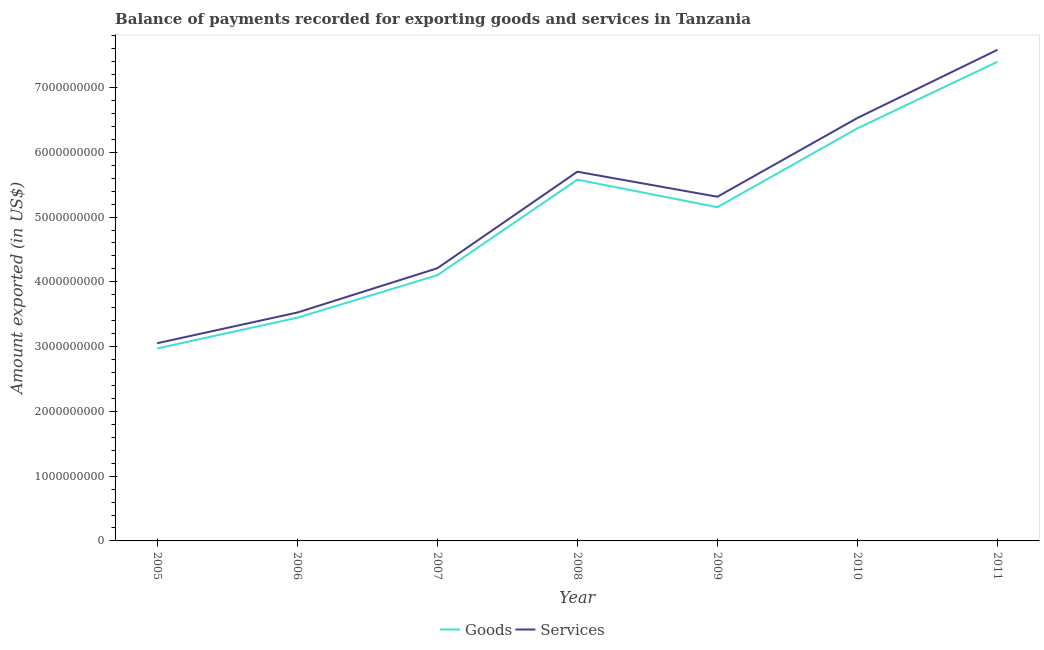How many different coloured lines are there?
Provide a short and direct response. 2. Is the number of lines equal to the number of legend labels?
Your answer should be compact. Yes. What is the amount of goods exported in 2011?
Your answer should be very brief. 7.40e+09. Across all years, what is the maximum amount of services exported?
Provide a succinct answer. 7.58e+09. Across all years, what is the minimum amount of services exported?
Offer a very short reply. 3.05e+09. In which year was the amount of services exported maximum?
Keep it short and to the point. 2011. In which year was the amount of services exported minimum?
Your response must be concise. 2005. What is the total amount of goods exported in the graph?
Your answer should be compact. 3.50e+1. What is the difference between the amount of goods exported in 2005 and that in 2007?
Offer a very short reply. -1.13e+09. What is the difference between the amount of services exported in 2011 and the amount of goods exported in 2005?
Offer a terse response. 4.61e+09. What is the average amount of goods exported per year?
Provide a succinct answer. 5.00e+09. In the year 2005, what is the difference between the amount of goods exported and amount of services exported?
Offer a very short reply. -8.09e+07. What is the ratio of the amount of services exported in 2006 to that in 2011?
Offer a terse response. 0.47. Is the difference between the amount of services exported in 2009 and 2010 greater than the difference between the amount of goods exported in 2009 and 2010?
Your answer should be compact. Yes. What is the difference between the highest and the second highest amount of goods exported?
Provide a succinct answer. 1.03e+09. What is the difference between the highest and the lowest amount of goods exported?
Give a very brief answer. 4.43e+09. In how many years, is the amount of goods exported greater than the average amount of goods exported taken over all years?
Provide a short and direct response. 4. Does the amount of goods exported monotonically increase over the years?
Ensure brevity in your answer.  No. Is the amount of goods exported strictly less than the amount of services exported over the years?
Provide a succinct answer. Yes. How many years are there in the graph?
Ensure brevity in your answer.  7. What is the difference between two consecutive major ticks on the Y-axis?
Your answer should be compact. 1.00e+09. Are the values on the major ticks of Y-axis written in scientific E-notation?
Offer a terse response. No. Does the graph contain any zero values?
Your response must be concise. No. Where does the legend appear in the graph?
Keep it short and to the point. Bottom center. How are the legend labels stacked?
Offer a very short reply. Horizontal. What is the title of the graph?
Make the answer very short. Balance of payments recorded for exporting goods and services in Tanzania. Does "Long-term debt" appear as one of the legend labels in the graph?
Make the answer very short. No. What is the label or title of the Y-axis?
Your response must be concise. Amount exported (in US$). What is the Amount exported (in US$) of Goods in 2005?
Provide a short and direct response. 2.97e+09. What is the Amount exported (in US$) in Services in 2005?
Your answer should be very brief. 3.05e+09. What is the Amount exported (in US$) of Goods in 2006?
Your answer should be compact. 3.45e+09. What is the Amount exported (in US$) of Services in 2006?
Offer a very short reply. 3.53e+09. What is the Amount exported (in US$) of Goods in 2007?
Keep it short and to the point. 4.10e+09. What is the Amount exported (in US$) in Services in 2007?
Give a very brief answer. 4.21e+09. What is the Amount exported (in US$) of Goods in 2008?
Your answer should be very brief. 5.58e+09. What is the Amount exported (in US$) in Services in 2008?
Your answer should be very brief. 5.70e+09. What is the Amount exported (in US$) of Goods in 2009?
Offer a very short reply. 5.15e+09. What is the Amount exported (in US$) of Services in 2009?
Offer a terse response. 5.31e+09. What is the Amount exported (in US$) of Goods in 2010?
Make the answer very short. 6.37e+09. What is the Amount exported (in US$) in Services in 2010?
Ensure brevity in your answer.  6.53e+09. What is the Amount exported (in US$) of Goods in 2011?
Your answer should be compact. 7.40e+09. What is the Amount exported (in US$) in Services in 2011?
Your answer should be very brief. 7.58e+09. Across all years, what is the maximum Amount exported (in US$) in Goods?
Your answer should be very brief. 7.40e+09. Across all years, what is the maximum Amount exported (in US$) of Services?
Your answer should be compact. 7.58e+09. Across all years, what is the minimum Amount exported (in US$) in Goods?
Give a very brief answer. 2.97e+09. Across all years, what is the minimum Amount exported (in US$) in Services?
Provide a succinct answer. 3.05e+09. What is the total Amount exported (in US$) of Goods in the graph?
Give a very brief answer. 3.50e+1. What is the total Amount exported (in US$) of Services in the graph?
Your answer should be compact. 3.59e+1. What is the difference between the Amount exported (in US$) of Goods in 2005 and that in 2006?
Your answer should be compact. -4.74e+08. What is the difference between the Amount exported (in US$) in Services in 2005 and that in 2006?
Offer a terse response. -4.73e+08. What is the difference between the Amount exported (in US$) in Goods in 2005 and that in 2007?
Give a very brief answer. -1.13e+09. What is the difference between the Amount exported (in US$) of Services in 2005 and that in 2007?
Keep it short and to the point. -1.16e+09. What is the difference between the Amount exported (in US$) in Goods in 2005 and that in 2008?
Ensure brevity in your answer.  -2.61e+09. What is the difference between the Amount exported (in US$) of Services in 2005 and that in 2008?
Provide a short and direct response. -2.65e+09. What is the difference between the Amount exported (in US$) in Goods in 2005 and that in 2009?
Your answer should be very brief. -2.18e+09. What is the difference between the Amount exported (in US$) in Services in 2005 and that in 2009?
Your response must be concise. -2.26e+09. What is the difference between the Amount exported (in US$) of Goods in 2005 and that in 2010?
Give a very brief answer. -3.40e+09. What is the difference between the Amount exported (in US$) of Services in 2005 and that in 2010?
Make the answer very short. -3.48e+09. What is the difference between the Amount exported (in US$) of Goods in 2005 and that in 2011?
Your answer should be compact. -4.43e+09. What is the difference between the Amount exported (in US$) in Services in 2005 and that in 2011?
Keep it short and to the point. -4.53e+09. What is the difference between the Amount exported (in US$) of Goods in 2006 and that in 2007?
Provide a succinct answer. -6.57e+08. What is the difference between the Amount exported (in US$) in Services in 2006 and that in 2007?
Provide a short and direct response. -6.84e+08. What is the difference between the Amount exported (in US$) of Goods in 2006 and that in 2008?
Keep it short and to the point. -2.13e+09. What is the difference between the Amount exported (in US$) of Services in 2006 and that in 2008?
Keep it short and to the point. -2.17e+09. What is the difference between the Amount exported (in US$) in Goods in 2006 and that in 2009?
Provide a short and direct response. -1.71e+09. What is the difference between the Amount exported (in US$) of Services in 2006 and that in 2009?
Ensure brevity in your answer.  -1.79e+09. What is the difference between the Amount exported (in US$) in Goods in 2006 and that in 2010?
Your answer should be very brief. -2.92e+09. What is the difference between the Amount exported (in US$) in Services in 2006 and that in 2010?
Offer a very short reply. -3.00e+09. What is the difference between the Amount exported (in US$) in Goods in 2006 and that in 2011?
Your answer should be very brief. -3.95e+09. What is the difference between the Amount exported (in US$) in Services in 2006 and that in 2011?
Offer a terse response. -4.06e+09. What is the difference between the Amount exported (in US$) in Goods in 2007 and that in 2008?
Ensure brevity in your answer.  -1.48e+09. What is the difference between the Amount exported (in US$) in Services in 2007 and that in 2008?
Offer a very short reply. -1.49e+09. What is the difference between the Amount exported (in US$) in Goods in 2007 and that in 2009?
Give a very brief answer. -1.05e+09. What is the difference between the Amount exported (in US$) of Services in 2007 and that in 2009?
Make the answer very short. -1.10e+09. What is the difference between the Amount exported (in US$) of Goods in 2007 and that in 2010?
Offer a terse response. -2.27e+09. What is the difference between the Amount exported (in US$) of Services in 2007 and that in 2010?
Your answer should be very brief. -2.32e+09. What is the difference between the Amount exported (in US$) of Goods in 2007 and that in 2011?
Make the answer very short. -3.30e+09. What is the difference between the Amount exported (in US$) in Services in 2007 and that in 2011?
Keep it short and to the point. -3.37e+09. What is the difference between the Amount exported (in US$) of Goods in 2008 and that in 2009?
Your answer should be very brief. 4.25e+08. What is the difference between the Amount exported (in US$) of Services in 2008 and that in 2009?
Make the answer very short. 3.86e+08. What is the difference between the Amount exported (in US$) of Goods in 2008 and that in 2010?
Provide a short and direct response. -7.92e+08. What is the difference between the Amount exported (in US$) of Services in 2008 and that in 2010?
Offer a terse response. -8.30e+08. What is the difference between the Amount exported (in US$) in Goods in 2008 and that in 2011?
Give a very brief answer. -1.82e+09. What is the difference between the Amount exported (in US$) of Services in 2008 and that in 2011?
Your response must be concise. -1.88e+09. What is the difference between the Amount exported (in US$) of Goods in 2009 and that in 2010?
Your answer should be very brief. -1.22e+09. What is the difference between the Amount exported (in US$) of Services in 2009 and that in 2010?
Offer a terse response. -1.22e+09. What is the difference between the Amount exported (in US$) in Goods in 2009 and that in 2011?
Make the answer very short. -2.25e+09. What is the difference between the Amount exported (in US$) of Services in 2009 and that in 2011?
Offer a very short reply. -2.27e+09. What is the difference between the Amount exported (in US$) of Goods in 2010 and that in 2011?
Your answer should be compact. -1.03e+09. What is the difference between the Amount exported (in US$) in Services in 2010 and that in 2011?
Your answer should be compact. -1.05e+09. What is the difference between the Amount exported (in US$) of Goods in 2005 and the Amount exported (in US$) of Services in 2006?
Provide a short and direct response. -5.54e+08. What is the difference between the Amount exported (in US$) of Goods in 2005 and the Amount exported (in US$) of Services in 2007?
Your answer should be compact. -1.24e+09. What is the difference between the Amount exported (in US$) in Goods in 2005 and the Amount exported (in US$) in Services in 2008?
Give a very brief answer. -2.73e+09. What is the difference between the Amount exported (in US$) of Goods in 2005 and the Amount exported (in US$) of Services in 2009?
Offer a terse response. -2.34e+09. What is the difference between the Amount exported (in US$) of Goods in 2005 and the Amount exported (in US$) of Services in 2010?
Offer a very short reply. -3.56e+09. What is the difference between the Amount exported (in US$) of Goods in 2005 and the Amount exported (in US$) of Services in 2011?
Offer a very short reply. -4.61e+09. What is the difference between the Amount exported (in US$) in Goods in 2006 and the Amount exported (in US$) in Services in 2007?
Ensure brevity in your answer.  -7.64e+08. What is the difference between the Amount exported (in US$) of Goods in 2006 and the Amount exported (in US$) of Services in 2008?
Offer a terse response. -2.25e+09. What is the difference between the Amount exported (in US$) of Goods in 2006 and the Amount exported (in US$) of Services in 2009?
Ensure brevity in your answer.  -1.87e+09. What is the difference between the Amount exported (in US$) of Goods in 2006 and the Amount exported (in US$) of Services in 2010?
Your answer should be compact. -3.08e+09. What is the difference between the Amount exported (in US$) of Goods in 2006 and the Amount exported (in US$) of Services in 2011?
Ensure brevity in your answer.  -4.14e+09. What is the difference between the Amount exported (in US$) in Goods in 2007 and the Amount exported (in US$) in Services in 2008?
Provide a short and direct response. -1.60e+09. What is the difference between the Amount exported (in US$) in Goods in 2007 and the Amount exported (in US$) in Services in 2009?
Offer a terse response. -1.21e+09. What is the difference between the Amount exported (in US$) of Goods in 2007 and the Amount exported (in US$) of Services in 2010?
Ensure brevity in your answer.  -2.43e+09. What is the difference between the Amount exported (in US$) in Goods in 2007 and the Amount exported (in US$) in Services in 2011?
Ensure brevity in your answer.  -3.48e+09. What is the difference between the Amount exported (in US$) of Goods in 2008 and the Amount exported (in US$) of Services in 2009?
Offer a terse response. 2.64e+08. What is the difference between the Amount exported (in US$) of Goods in 2008 and the Amount exported (in US$) of Services in 2010?
Make the answer very short. -9.53e+08. What is the difference between the Amount exported (in US$) in Goods in 2008 and the Amount exported (in US$) in Services in 2011?
Offer a very short reply. -2.00e+09. What is the difference between the Amount exported (in US$) in Goods in 2009 and the Amount exported (in US$) in Services in 2010?
Provide a succinct answer. -1.38e+09. What is the difference between the Amount exported (in US$) of Goods in 2009 and the Amount exported (in US$) of Services in 2011?
Provide a short and direct response. -2.43e+09. What is the difference between the Amount exported (in US$) of Goods in 2010 and the Amount exported (in US$) of Services in 2011?
Give a very brief answer. -1.21e+09. What is the average Amount exported (in US$) of Goods per year?
Provide a succinct answer. 5.00e+09. What is the average Amount exported (in US$) of Services per year?
Give a very brief answer. 5.13e+09. In the year 2005, what is the difference between the Amount exported (in US$) in Goods and Amount exported (in US$) in Services?
Keep it short and to the point. -8.09e+07. In the year 2006, what is the difference between the Amount exported (in US$) of Goods and Amount exported (in US$) of Services?
Your response must be concise. -8.03e+07. In the year 2007, what is the difference between the Amount exported (in US$) in Goods and Amount exported (in US$) in Services?
Offer a terse response. -1.07e+08. In the year 2008, what is the difference between the Amount exported (in US$) in Goods and Amount exported (in US$) in Services?
Ensure brevity in your answer.  -1.23e+08. In the year 2009, what is the difference between the Amount exported (in US$) of Goods and Amount exported (in US$) of Services?
Your answer should be very brief. -1.61e+08. In the year 2010, what is the difference between the Amount exported (in US$) of Goods and Amount exported (in US$) of Services?
Offer a very short reply. -1.60e+08. In the year 2011, what is the difference between the Amount exported (in US$) of Goods and Amount exported (in US$) of Services?
Keep it short and to the point. -1.84e+08. What is the ratio of the Amount exported (in US$) in Goods in 2005 to that in 2006?
Your answer should be very brief. 0.86. What is the ratio of the Amount exported (in US$) of Services in 2005 to that in 2006?
Provide a short and direct response. 0.87. What is the ratio of the Amount exported (in US$) of Goods in 2005 to that in 2007?
Your answer should be very brief. 0.72. What is the ratio of the Amount exported (in US$) in Services in 2005 to that in 2007?
Offer a terse response. 0.73. What is the ratio of the Amount exported (in US$) in Goods in 2005 to that in 2008?
Your answer should be compact. 0.53. What is the ratio of the Amount exported (in US$) of Services in 2005 to that in 2008?
Offer a very short reply. 0.54. What is the ratio of the Amount exported (in US$) of Goods in 2005 to that in 2009?
Provide a short and direct response. 0.58. What is the ratio of the Amount exported (in US$) of Services in 2005 to that in 2009?
Your answer should be compact. 0.57. What is the ratio of the Amount exported (in US$) in Goods in 2005 to that in 2010?
Provide a short and direct response. 0.47. What is the ratio of the Amount exported (in US$) of Services in 2005 to that in 2010?
Provide a succinct answer. 0.47. What is the ratio of the Amount exported (in US$) in Goods in 2005 to that in 2011?
Ensure brevity in your answer.  0.4. What is the ratio of the Amount exported (in US$) in Services in 2005 to that in 2011?
Your answer should be compact. 0.4. What is the ratio of the Amount exported (in US$) in Goods in 2006 to that in 2007?
Your response must be concise. 0.84. What is the ratio of the Amount exported (in US$) in Services in 2006 to that in 2007?
Give a very brief answer. 0.84. What is the ratio of the Amount exported (in US$) of Goods in 2006 to that in 2008?
Keep it short and to the point. 0.62. What is the ratio of the Amount exported (in US$) of Services in 2006 to that in 2008?
Make the answer very short. 0.62. What is the ratio of the Amount exported (in US$) of Goods in 2006 to that in 2009?
Provide a short and direct response. 0.67. What is the ratio of the Amount exported (in US$) of Services in 2006 to that in 2009?
Make the answer very short. 0.66. What is the ratio of the Amount exported (in US$) of Goods in 2006 to that in 2010?
Your answer should be very brief. 0.54. What is the ratio of the Amount exported (in US$) in Services in 2006 to that in 2010?
Your answer should be very brief. 0.54. What is the ratio of the Amount exported (in US$) in Goods in 2006 to that in 2011?
Offer a very short reply. 0.47. What is the ratio of the Amount exported (in US$) of Services in 2006 to that in 2011?
Provide a succinct answer. 0.47. What is the ratio of the Amount exported (in US$) in Goods in 2007 to that in 2008?
Provide a succinct answer. 0.74. What is the ratio of the Amount exported (in US$) of Services in 2007 to that in 2008?
Give a very brief answer. 0.74. What is the ratio of the Amount exported (in US$) in Goods in 2007 to that in 2009?
Your response must be concise. 0.8. What is the ratio of the Amount exported (in US$) of Services in 2007 to that in 2009?
Your answer should be very brief. 0.79. What is the ratio of the Amount exported (in US$) of Goods in 2007 to that in 2010?
Offer a very short reply. 0.64. What is the ratio of the Amount exported (in US$) of Services in 2007 to that in 2010?
Ensure brevity in your answer.  0.64. What is the ratio of the Amount exported (in US$) of Goods in 2007 to that in 2011?
Your answer should be very brief. 0.55. What is the ratio of the Amount exported (in US$) in Services in 2007 to that in 2011?
Provide a short and direct response. 0.56. What is the ratio of the Amount exported (in US$) in Goods in 2008 to that in 2009?
Make the answer very short. 1.08. What is the ratio of the Amount exported (in US$) in Services in 2008 to that in 2009?
Ensure brevity in your answer.  1.07. What is the ratio of the Amount exported (in US$) in Goods in 2008 to that in 2010?
Keep it short and to the point. 0.88. What is the ratio of the Amount exported (in US$) in Services in 2008 to that in 2010?
Your answer should be very brief. 0.87. What is the ratio of the Amount exported (in US$) of Goods in 2008 to that in 2011?
Give a very brief answer. 0.75. What is the ratio of the Amount exported (in US$) of Services in 2008 to that in 2011?
Keep it short and to the point. 0.75. What is the ratio of the Amount exported (in US$) in Goods in 2009 to that in 2010?
Make the answer very short. 0.81. What is the ratio of the Amount exported (in US$) of Services in 2009 to that in 2010?
Provide a succinct answer. 0.81. What is the ratio of the Amount exported (in US$) of Goods in 2009 to that in 2011?
Provide a short and direct response. 0.7. What is the ratio of the Amount exported (in US$) in Services in 2009 to that in 2011?
Provide a short and direct response. 0.7. What is the ratio of the Amount exported (in US$) of Goods in 2010 to that in 2011?
Keep it short and to the point. 0.86. What is the ratio of the Amount exported (in US$) in Services in 2010 to that in 2011?
Make the answer very short. 0.86. What is the difference between the highest and the second highest Amount exported (in US$) of Goods?
Your answer should be compact. 1.03e+09. What is the difference between the highest and the second highest Amount exported (in US$) in Services?
Provide a succinct answer. 1.05e+09. What is the difference between the highest and the lowest Amount exported (in US$) of Goods?
Your response must be concise. 4.43e+09. What is the difference between the highest and the lowest Amount exported (in US$) of Services?
Make the answer very short. 4.53e+09. 